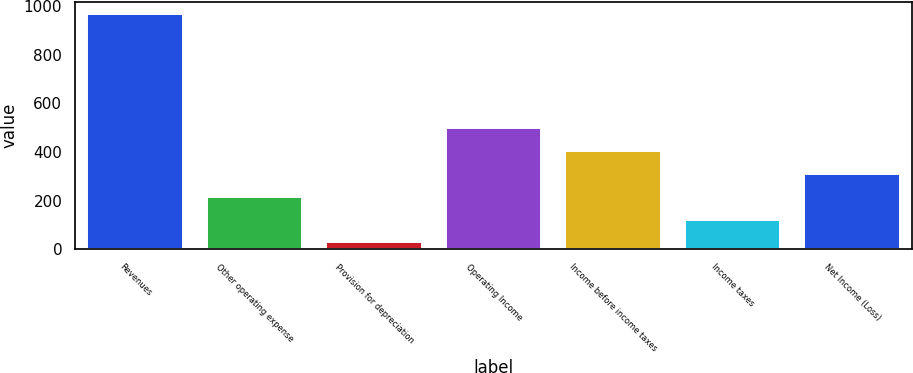<chart> <loc_0><loc_0><loc_500><loc_500><bar_chart><fcel>Revenues<fcel>Other operating expense<fcel>Provision for depreciation<fcel>Operating Income<fcel>Income before income taxes<fcel>Income taxes<fcel>Net Income (Loss)<nl><fcel>968<fcel>216<fcel>28<fcel>498<fcel>404<fcel>122<fcel>310<nl></chart> 